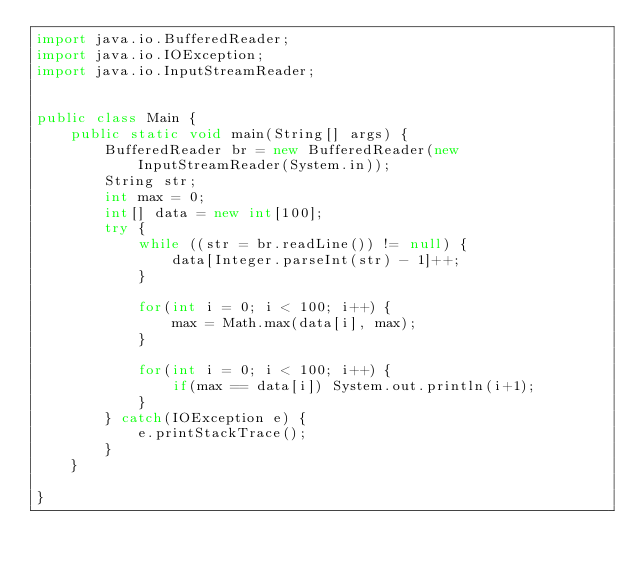<code> <loc_0><loc_0><loc_500><loc_500><_Java_>import java.io.BufferedReader;
import java.io.IOException;
import java.io.InputStreamReader;


public class Main {
	public static void main(String[] args) {
		BufferedReader br = new BufferedReader(new InputStreamReader(System.in));
		String str;
		int max = 0;
		int[] data = new int[100];
		try {
			while ((str = br.readLine()) != null) {
				data[Integer.parseInt(str) - 1]++;
			}
			
			for(int i = 0; i < 100; i++) {
				max = Math.max(data[i], max);
			}
			
			for(int i = 0; i < 100; i++) {
				if(max == data[i]) System.out.println(i+1);
			}
		} catch(IOException e) {
			e.printStackTrace();
		}
	}

}</code> 